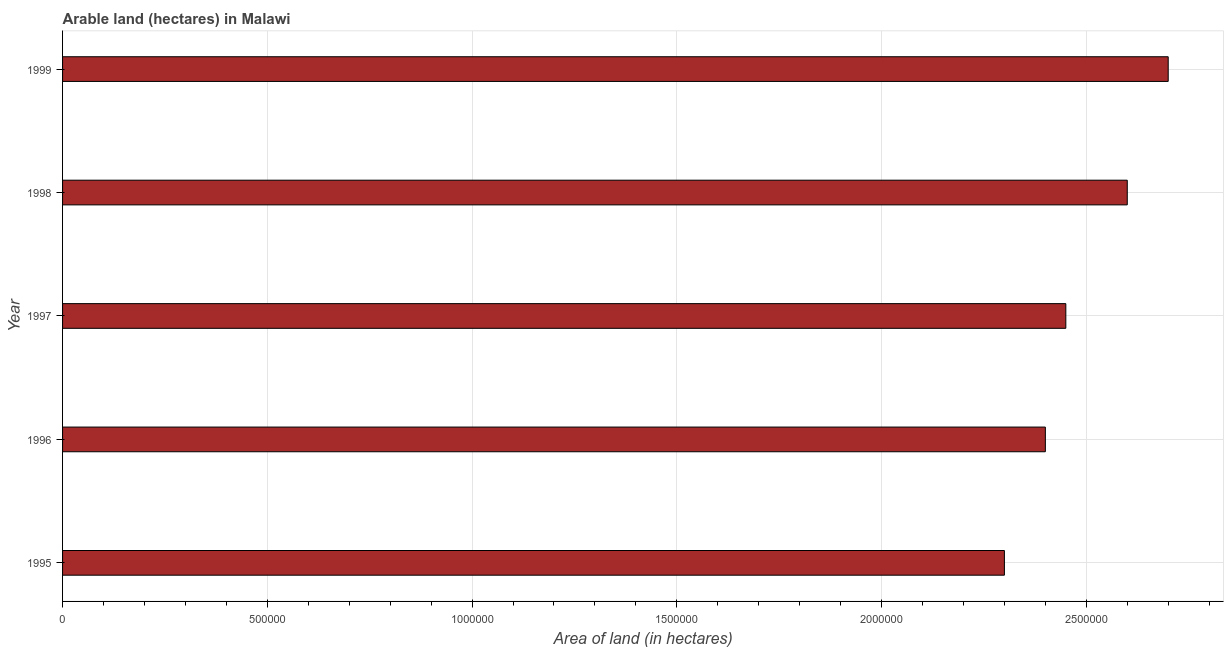What is the title of the graph?
Your answer should be compact. Arable land (hectares) in Malawi. What is the label or title of the X-axis?
Give a very brief answer. Area of land (in hectares). What is the label or title of the Y-axis?
Ensure brevity in your answer.  Year. What is the area of land in 1996?
Give a very brief answer. 2.40e+06. Across all years, what is the maximum area of land?
Make the answer very short. 2.70e+06. Across all years, what is the minimum area of land?
Ensure brevity in your answer.  2.30e+06. In which year was the area of land maximum?
Offer a very short reply. 1999. In which year was the area of land minimum?
Make the answer very short. 1995. What is the sum of the area of land?
Give a very brief answer. 1.24e+07. What is the difference between the area of land in 1996 and 1998?
Offer a very short reply. -2.00e+05. What is the average area of land per year?
Give a very brief answer. 2.49e+06. What is the median area of land?
Provide a succinct answer. 2.45e+06. In how many years, is the area of land greater than 200000 hectares?
Your answer should be compact. 5. Do a majority of the years between 1997 and 1996 (inclusive) have area of land greater than 400000 hectares?
Provide a short and direct response. No. Is the area of land in 1997 less than that in 1998?
Keep it short and to the point. Yes. What is the difference between the highest and the second highest area of land?
Give a very brief answer. 1.00e+05. Is the sum of the area of land in 1995 and 1998 greater than the maximum area of land across all years?
Make the answer very short. Yes. What is the difference between the highest and the lowest area of land?
Give a very brief answer. 4.00e+05. In how many years, is the area of land greater than the average area of land taken over all years?
Ensure brevity in your answer.  2. How many bars are there?
Your answer should be compact. 5. How many years are there in the graph?
Offer a terse response. 5. What is the difference between two consecutive major ticks on the X-axis?
Make the answer very short. 5.00e+05. What is the Area of land (in hectares) in 1995?
Give a very brief answer. 2.30e+06. What is the Area of land (in hectares) of 1996?
Your answer should be compact. 2.40e+06. What is the Area of land (in hectares) in 1997?
Keep it short and to the point. 2.45e+06. What is the Area of land (in hectares) in 1998?
Ensure brevity in your answer.  2.60e+06. What is the Area of land (in hectares) in 1999?
Your answer should be very brief. 2.70e+06. What is the difference between the Area of land (in hectares) in 1995 and 1997?
Offer a terse response. -1.50e+05. What is the difference between the Area of land (in hectares) in 1995 and 1999?
Your answer should be compact. -4.00e+05. What is the difference between the Area of land (in hectares) in 1996 and 1997?
Your response must be concise. -5.00e+04. What is the difference between the Area of land (in hectares) in 1996 and 1998?
Ensure brevity in your answer.  -2.00e+05. What is the difference between the Area of land (in hectares) in 1997 and 1998?
Give a very brief answer. -1.50e+05. What is the difference between the Area of land (in hectares) in 1998 and 1999?
Offer a very short reply. -1.00e+05. What is the ratio of the Area of land (in hectares) in 1995 to that in 1996?
Offer a very short reply. 0.96. What is the ratio of the Area of land (in hectares) in 1995 to that in 1997?
Ensure brevity in your answer.  0.94. What is the ratio of the Area of land (in hectares) in 1995 to that in 1998?
Offer a terse response. 0.89. What is the ratio of the Area of land (in hectares) in 1995 to that in 1999?
Keep it short and to the point. 0.85. What is the ratio of the Area of land (in hectares) in 1996 to that in 1997?
Provide a succinct answer. 0.98. What is the ratio of the Area of land (in hectares) in 1996 to that in 1998?
Offer a very short reply. 0.92. What is the ratio of the Area of land (in hectares) in 1996 to that in 1999?
Your answer should be very brief. 0.89. What is the ratio of the Area of land (in hectares) in 1997 to that in 1998?
Ensure brevity in your answer.  0.94. What is the ratio of the Area of land (in hectares) in 1997 to that in 1999?
Offer a terse response. 0.91. What is the ratio of the Area of land (in hectares) in 1998 to that in 1999?
Your answer should be compact. 0.96. 